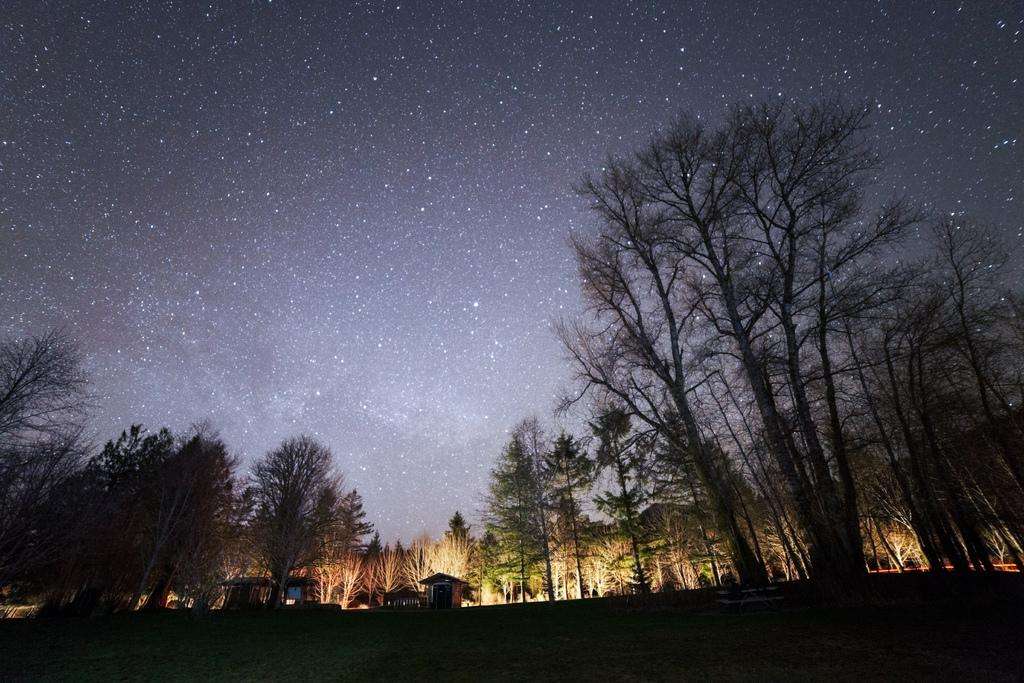What type of structures can be seen in the image? There are houses in the image. What other natural elements are present in the image? There are trees in the image. Is there any seating visible in the image? Yes, there is a bench in the image. What can be seen in the sky in the background of the image? In the background, there are stars visible in the sky. What color is the paint on the bee in the image? There is no bee present in the image, so there is no paint to describe. 